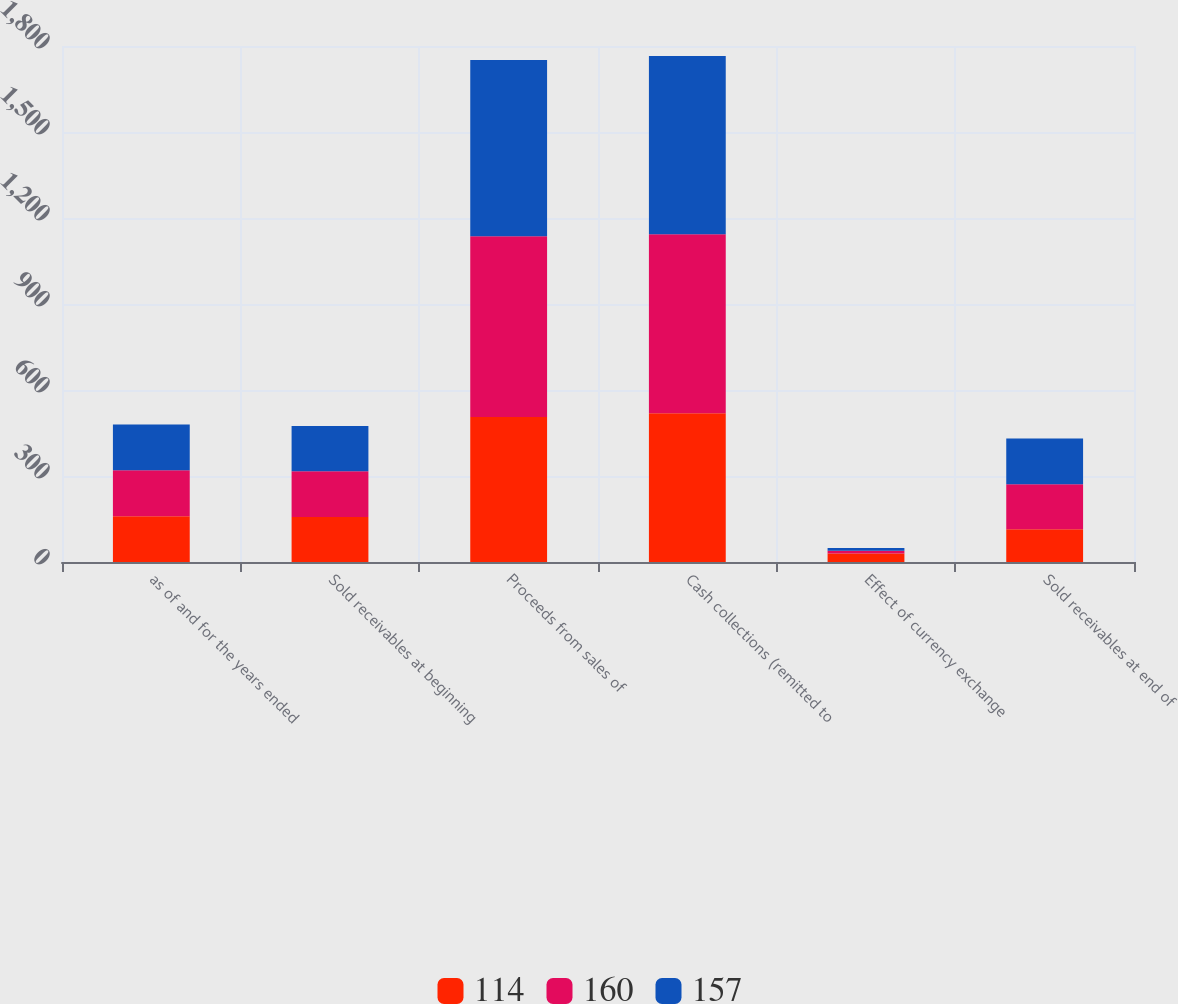Convert chart to OTSL. <chart><loc_0><loc_0><loc_500><loc_500><stacked_bar_chart><ecel><fcel>as of and for the years ended<fcel>Sold receivables at beginning<fcel>Proceeds from sales of<fcel>Cash collections (remitted to<fcel>Effect of currency exchange<fcel>Sold receivables at end of<nl><fcel>114<fcel>160<fcel>157<fcel>506<fcel>519<fcel>30<fcel>114<nl><fcel>160<fcel>160<fcel>160<fcel>630<fcel>624<fcel>9<fcel>157<nl><fcel>157<fcel>160<fcel>157<fcel>615<fcel>622<fcel>10<fcel>160<nl></chart> 